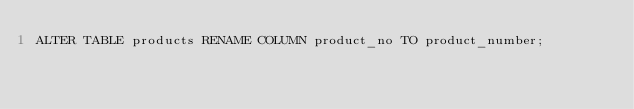Convert code to text. <code><loc_0><loc_0><loc_500><loc_500><_SQL_>ALTER TABLE products RENAME COLUMN product_no TO product_number;
</code> 